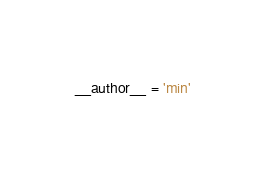<code> <loc_0><loc_0><loc_500><loc_500><_Python_>__author__ = 'min'
</code> 